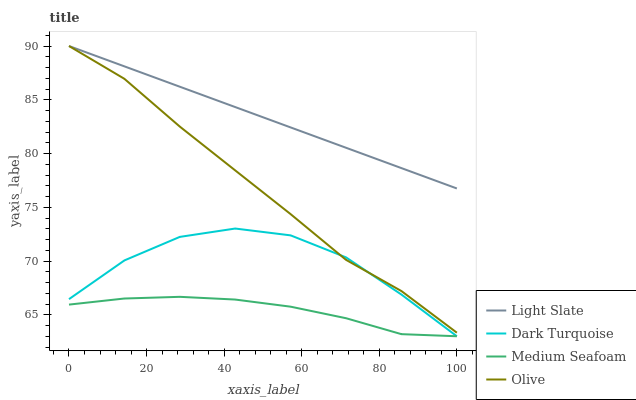Does Medium Seafoam have the minimum area under the curve?
Answer yes or no. Yes. Does Light Slate have the maximum area under the curve?
Answer yes or no. Yes. Does Dark Turquoise have the minimum area under the curve?
Answer yes or no. No. Does Dark Turquoise have the maximum area under the curve?
Answer yes or no. No. Is Light Slate the smoothest?
Answer yes or no. Yes. Is Dark Turquoise the roughest?
Answer yes or no. Yes. Is Medium Seafoam the smoothest?
Answer yes or no. No. Is Medium Seafoam the roughest?
Answer yes or no. No. Does Dark Turquoise have the lowest value?
Answer yes or no. Yes. Does Olive have the lowest value?
Answer yes or no. No. Does Olive have the highest value?
Answer yes or no. Yes. Does Dark Turquoise have the highest value?
Answer yes or no. No. Is Medium Seafoam less than Olive?
Answer yes or no. Yes. Is Light Slate greater than Dark Turquoise?
Answer yes or no. Yes. Does Medium Seafoam intersect Dark Turquoise?
Answer yes or no. Yes. Is Medium Seafoam less than Dark Turquoise?
Answer yes or no. No. Is Medium Seafoam greater than Dark Turquoise?
Answer yes or no. No. Does Medium Seafoam intersect Olive?
Answer yes or no. No. 